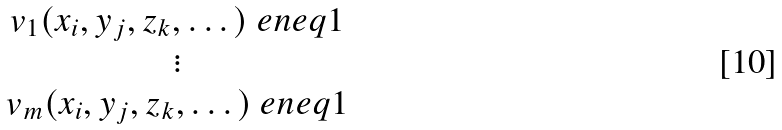<formula> <loc_0><loc_0><loc_500><loc_500>\begin{matrix} v _ { 1 } ( x _ { i } , y _ { j } , z _ { k } , \dots ) \ e n e q 1 \\ \vdots \\ v _ { m } ( x _ { i } , y _ { j } , z _ { k } , \dots ) \ e n e q 1 \end{matrix}</formula> 